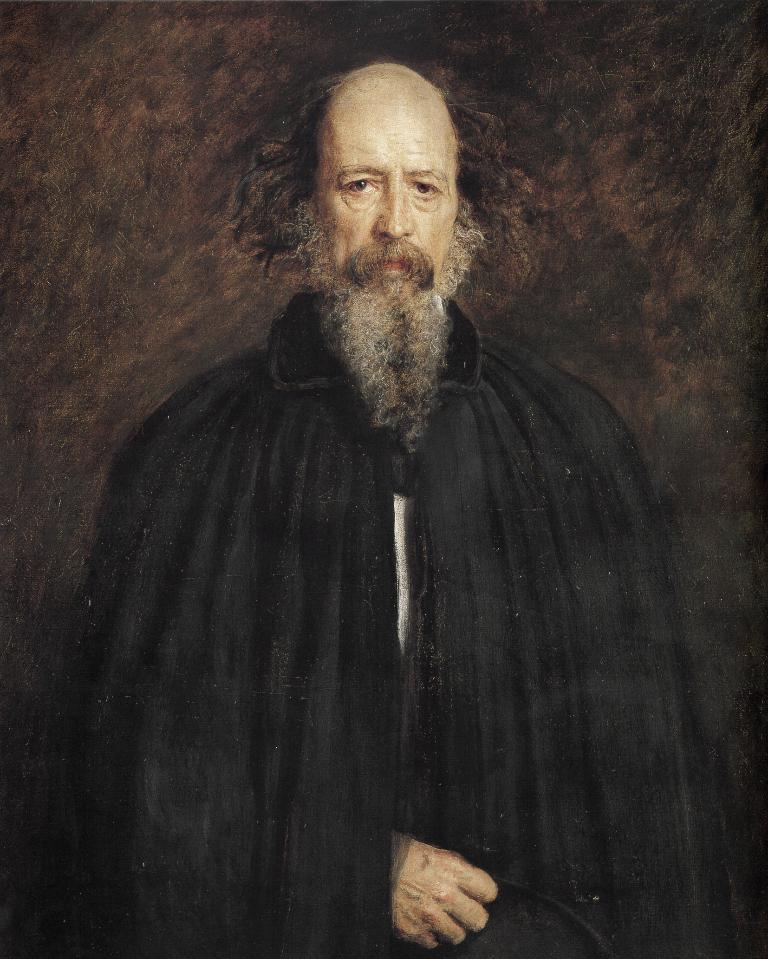What is the main subject of the image? There is a painting in the image. What is the painting depicting? The painting depicts a person standing. Where is the person located within the painting? The person is in the middle of the image. What type of government is depicted in the painting? There is no depiction of a government in the painting; it features a person standing. Can you tell me how many bats are flying around the person in the painting? There are no bats present in the painting; it only features a person standing. 